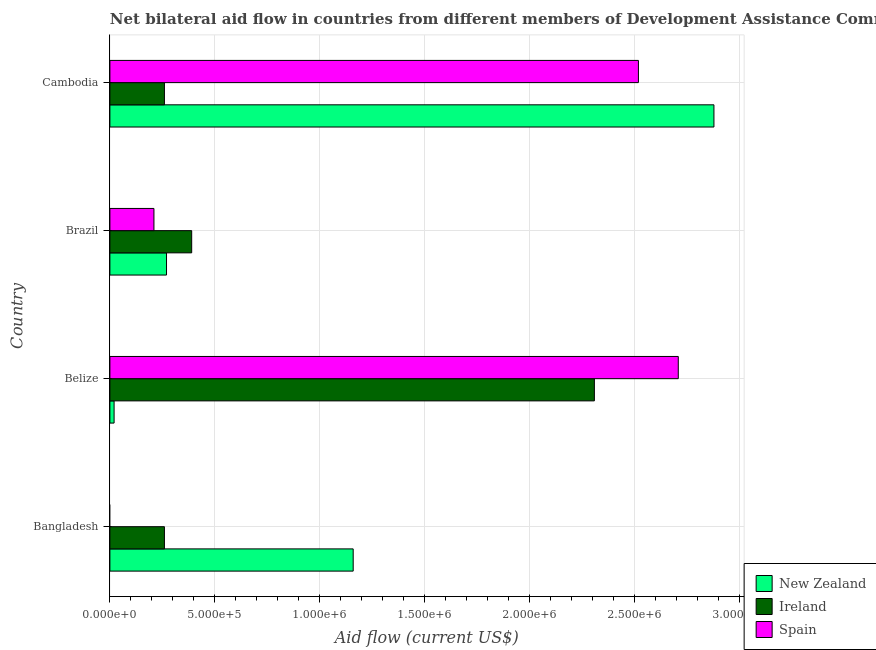How many different coloured bars are there?
Your response must be concise. 3. Are the number of bars per tick equal to the number of legend labels?
Offer a very short reply. No. Are the number of bars on each tick of the Y-axis equal?
Make the answer very short. No. What is the label of the 1st group of bars from the top?
Offer a very short reply. Cambodia. What is the amount of aid provided by spain in Bangladesh?
Provide a succinct answer. 0. Across all countries, what is the maximum amount of aid provided by spain?
Offer a very short reply. 2.71e+06. Across all countries, what is the minimum amount of aid provided by spain?
Provide a succinct answer. 0. In which country was the amount of aid provided by new zealand maximum?
Your answer should be very brief. Cambodia. What is the total amount of aid provided by spain in the graph?
Provide a short and direct response. 5.44e+06. What is the difference between the amount of aid provided by spain in Belize and that in Brazil?
Keep it short and to the point. 2.50e+06. What is the difference between the amount of aid provided by new zealand in Bangladesh and the amount of aid provided by ireland in Brazil?
Keep it short and to the point. 7.70e+05. What is the average amount of aid provided by spain per country?
Your answer should be very brief. 1.36e+06. What is the difference between the amount of aid provided by spain and amount of aid provided by new zealand in Belize?
Make the answer very short. 2.69e+06. In how many countries, is the amount of aid provided by new zealand greater than 1300000 US$?
Give a very brief answer. 1. What is the ratio of the amount of aid provided by new zealand in Bangladesh to that in Cambodia?
Your answer should be very brief. 0.4. Is the amount of aid provided by new zealand in Bangladesh less than that in Brazil?
Give a very brief answer. No. What is the difference between the highest and the second highest amount of aid provided by new zealand?
Ensure brevity in your answer.  1.72e+06. What is the difference between the highest and the lowest amount of aid provided by spain?
Keep it short and to the point. 2.71e+06. Is the sum of the amount of aid provided by new zealand in Belize and Brazil greater than the maximum amount of aid provided by spain across all countries?
Keep it short and to the point. No. Is it the case that in every country, the sum of the amount of aid provided by new zealand and amount of aid provided by ireland is greater than the amount of aid provided by spain?
Ensure brevity in your answer.  No. How many countries are there in the graph?
Your response must be concise. 4. What is the difference between two consecutive major ticks on the X-axis?
Provide a succinct answer. 5.00e+05. Are the values on the major ticks of X-axis written in scientific E-notation?
Keep it short and to the point. Yes. How are the legend labels stacked?
Give a very brief answer. Vertical. What is the title of the graph?
Your answer should be compact. Net bilateral aid flow in countries from different members of Development Assistance Committee. Does "Maunufacturing" appear as one of the legend labels in the graph?
Your response must be concise. No. What is the label or title of the X-axis?
Offer a very short reply. Aid flow (current US$). What is the Aid flow (current US$) of New Zealand in Bangladesh?
Ensure brevity in your answer.  1.16e+06. What is the Aid flow (current US$) in Spain in Bangladesh?
Give a very brief answer. 0. What is the Aid flow (current US$) of Ireland in Belize?
Make the answer very short. 2.31e+06. What is the Aid flow (current US$) of Spain in Belize?
Provide a short and direct response. 2.71e+06. What is the Aid flow (current US$) of New Zealand in Brazil?
Make the answer very short. 2.70e+05. What is the Aid flow (current US$) of New Zealand in Cambodia?
Offer a very short reply. 2.88e+06. What is the Aid flow (current US$) in Spain in Cambodia?
Your response must be concise. 2.52e+06. Across all countries, what is the maximum Aid flow (current US$) in New Zealand?
Your answer should be compact. 2.88e+06. Across all countries, what is the maximum Aid flow (current US$) of Ireland?
Keep it short and to the point. 2.31e+06. Across all countries, what is the maximum Aid flow (current US$) of Spain?
Provide a succinct answer. 2.71e+06. Across all countries, what is the minimum Aid flow (current US$) in Ireland?
Keep it short and to the point. 2.60e+05. What is the total Aid flow (current US$) in New Zealand in the graph?
Make the answer very short. 4.33e+06. What is the total Aid flow (current US$) of Ireland in the graph?
Make the answer very short. 3.22e+06. What is the total Aid flow (current US$) in Spain in the graph?
Provide a short and direct response. 5.44e+06. What is the difference between the Aid flow (current US$) in New Zealand in Bangladesh and that in Belize?
Keep it short and to the point. 1.14e+06. What is the difference between the Aid flow (current US$) of Ireland in Bangladesh and that in Belize?
Your answer should be compact. -2.05e+06. What is the difference between the Aid flow (current US$) in New Zealand in Bangladesh and that in Brazil?
Your answer should be compact. 8.90e+05. What is the difference between the Aid flow (current US$) in New Zealand in Bangladesh and that in Cambodia?
Your answer should be very brief. -1.72e+06. What is the difference between the Aid flow (current US$) in Ireland in Belize and that in Brazil?
Provide a short and direct response. 1.92e+06. What is the difference between the Aid flow (current US$) in Spain in Belize and that in Brazil?
Your answer should be very brief. 2.50e+06. What is the difference between the Aid flow (current US$) in New Zealand in Belize and that in Cambodia?
Make the answer very short. -2.86e+06. What is the difference between the Aid flow (current US$) of Ireland in Belize and that in Cambodia?
Ensure brevity in your answer.  2.05e+06. What is the difference between the Aid flow (current US$) in Spain in Belize and that in Cambodia?
Your answer should be compact. 1.90e+05. What is the difference between the Aid flow (current US$) in New Zealand in Brazil and that in Cambodia?
Keep it short and to the point. -2.61e+06. What is the difference between the Aid flow (current US$) in Ireland in Brazil and that in Cambodia?
Offer a very short reply. 1.30e+05. What is the difference between the Aid flow (current US$) of Spain in Brazil and that in Cambodia?
Give a very brief answer. -2.31e+06. What is the difference between the Aid flow (current US$) of New Zealand in Bangladesh and the Aid flow (current US$) of Ireland in Belize?
Provide a succinct answer. -1.15e+06. What is the difference between the Aid flow (current US$) in New Zealand in Bangladesh and the Aid flow (current US$) in Spain in Belize?
Your response must be concise. -1.55e+06. What is the difference between the Aid flow (current US$) in Ireland in Bangladesh and the Aid flow (current US$) in Spain in Belize?
Keep it short and to the point. -2.45e+06. What is the difference between the Aid flow (current US$) in New Zealand in Bangladesh and the Aid flow (current US$) in Ireland in Brazil?
Make the answer very short. 7.70e+05. What is the difference between the Aid flow (current US$) in New Zealand in Bangladesh and the Aid flow (current US$) in Spain in Brazil?
Your response must be concise. 9.50e+05. What is the difference between the Aid flow (current US$) of Ireland in Bangladesh and the Aid flow (current US$) of Spain in Brazil?
Keep it short and to the point. 5.00e+04. What is the difference between the Aid flow (current US$) in New Zealand in Bangladesh and the Aid flow (current US$) in Spain in Cambodia?
Your answer should be compact. -1.36e+06. What is the difference between the Aid flow (current US$) in Ireland in Bangladesh and the Aid flow (current US$) in Spain in Cambodia?
Your answer should be compact. -2.26e+06. What is the difference between the Aid flow (current US$) in New Zealand in Belize and the Aid flow (current US$) in Ireland in Brazil?
Offer a very short reply. -3.70e+05. What is the difference between the Aid flow (current US$) of Ireland in Belize and the Aid flow (current US$) of Spain in Brazil?
Ensure brevity in your answer.  2.10e+06. What is the difference between the Aid flow (current US$) in New Zealand in Belize and the Aid flow (current US$) in Ireland in Cambodia?
Your answer should be very brief. -2.40e+05. What is the difference between the Aid flow (current US$) in New Zealand in Belize and the Aid flow (current US$) in Spain in Cambodia?
Your answer should be very brief. -2.50e+06. What is the difference between the Aid flow (current US$) in Ireland in Belize and the Aid flow (current US$) in Spain in Cambodia?
Provide a short and direct response. -2.10e+05. What is the difference between the Aid flow (current US$) in New Zealand in Brazil and the Aid flow (current US$) in Spain in Cambodia?
Provide a short and direct response. -2.25e+06. What is the difference between the Aid flow (current US$) of Ireland in Brazil and the Aid flow (current US$) of Spain in Cambodia?
Provide a succinct answer. -2.13e+06. What is the average Aid flow (current US$) in New Zealand per country?
Provide a succinct answer. 1.08e+06. What is the average Aid flow (current US$) in Ireland per country?
Ensure brevity in your answer.  8.05e+05. What is the average Aid flow (current US$) of Spain per country?
Provide a succinct answer. 1.36e+06. What is the difference between the Aid flow (current US$) of New Zealand and Aid flow (current US$) of Ireland in Bangladesh?
Provide a short and direct response. 9.00e+05. What is the difference between the Aid flow (current US$) in New Zealand and Aid flow (current US$) in Ireland in Belize?
Make the answer very short. -2.29e+06. What is the difference between the Aid flow (current US$) in New Zealand and Aid flow (current US$) in Spain in Belize?
Offer a terse response. -2.69e+06. What is the difference between the Aid flow (current US$) in Ireland and Aid flow (current US$) in Spain in Belize?
Ensure brevity in your answer.  -4.00e+05. What is the difference between the Aid flow (current US$) in New Zealand and Aid flow (current US$) in Spain in Brazil?
Your answer should be very brief. 6.00e+04. What is the difference between the Aid flow (current US$) of Ireland and Aid flow (current US$) of Spain in Brazil?
Your answer should be compact. 1.80e+05. What is the difference between the Aid flow (current US$) of New Zealand and Aid flow (current US$) of Ireland in Cambodia?
Your response must be concise. 2.62e+06. What is the difference between the Aid flow (current US$) in Ireland and Aid flow (current US$) in Spain in Cambodia?
Offer a very short reply. -2.26e+06. What is the ratio of the Aid flow (current US$) in Ireland in Bangladesh to that in Belize?
Make the answer very short. 0.11. What is the ratio of the Aid flow (current US$) of New Zealand in Bangladesh to that in Brazil?
Make the answer very short. 4.3. What is the ratio of the Aid flow (current US$) of Ireland in Bangladesh to that in Brazil?
Offer a terse response. 0.67. What is the ratio of the Aid flow (current US$) of New Zealand in Bangladesh to that in Cambodia?
Your answer should be compact. 0.4. What is the ratio of the Aid flow (current US$) of New Zealand in Belize to that in Brazil?
Your answer should be very brief. 0.07. What is the ratio of the Aid flow (current US$) of Ireland in Belize to that in Brazil?
Your answer should be very brief. 5.92. What is the ratio of the Aid flow (current US$) in Spain in Belize to that in Brazil?
Your answer should be compact. 12.9. What is the ratio of the Aid flow (current US$) of New Zealand in Belize to that in Cambodia?
Make the answer very short. 0.01. What is the ratio of the Aid flow (current US$) in Ireland in Belize to that in Cambodia?
Keep it short and to the point. 8.88. What is the ratio of the Aid flow (current US$) of Spain in Belize to that in Cambodia?
Provide a short and direct response. 1.08. What is the ratio of the Aid flow (current US$) in New Zealand in Brazil to that in Cambodia?
Offer a terse response. 0.09. What is the ratio of the Aid flow (current US$) in Spain in Brazil to that in Cambodia?
Offer a very short reply. 0.08. What is the difference between the highest and the second highest Aid flow (current US$) of New Zealand?
Offer a very short reply. 1.72e+06. What is the difference between the highest and the second highest Aid flow (current US$) of Ireland?
Make the answer very short. 1.92e+06. What is the difference between the highest and the second highest Aid flow (current US$) in Spain?
Offer a very short reply. 1.90e+05. What is the difference between the highest and the lowest Aid flow (current US$) in New Zealand?
Your answer should be compact. 2.86e+06. What is the difference between the highest and the lowest Aid flow (current US$) in Ireland?
Offer a very short reply. 2.05e+06. What is the difference between the highest and the lowest Aid flow (current US$) in Spain?
Ensure brevity in your answer.  2.71e+06. 